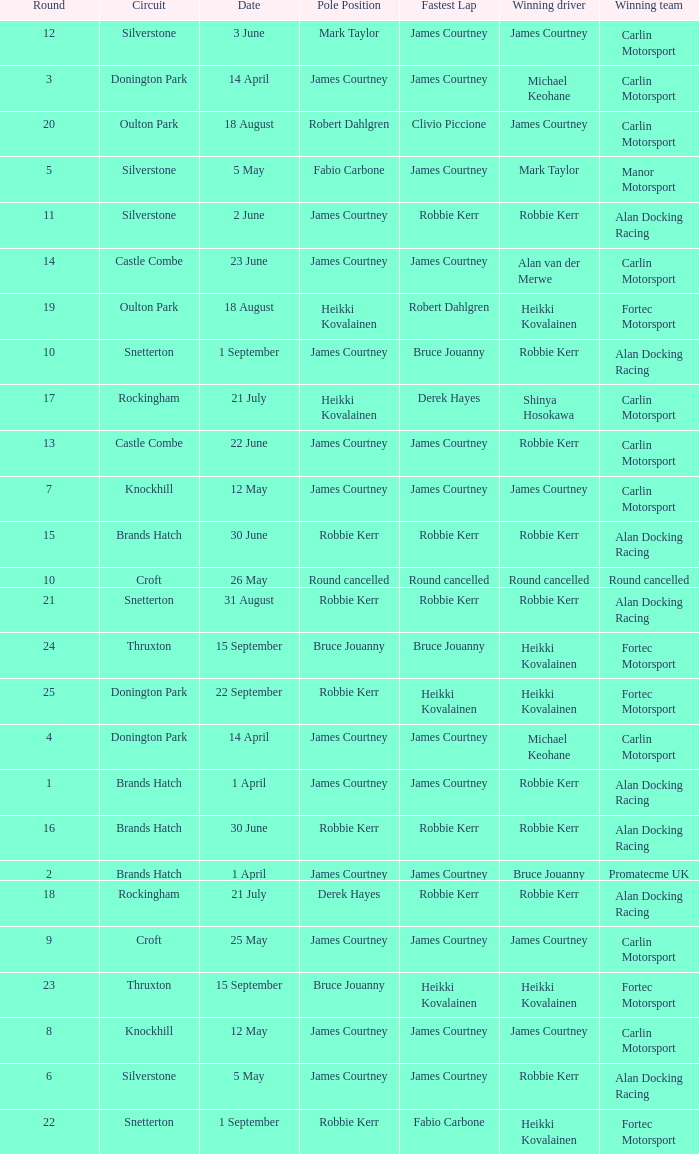What is every pole position for the Castle Combe circuit and Robbie Kerr is the winning driver? James Courtney. 